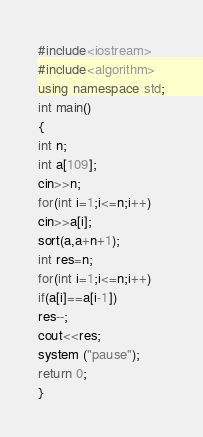<code> <loc_0><loc_0><loc_500><loc_500><_C++_>#include<iostream>
#include<algorithm>
using namespace std;
int main()
{
int n;
int a[109];
cin>>n;
for(int i=1;i<=n;i++)
cin>>a[i];
sort(a,a+n+1);
int res=n;
for(int i=1;i<=n;i++)
if(a[i]==a[i-1])
res--;
cout<<res;
system ("pause");
return 0;
}</code> 